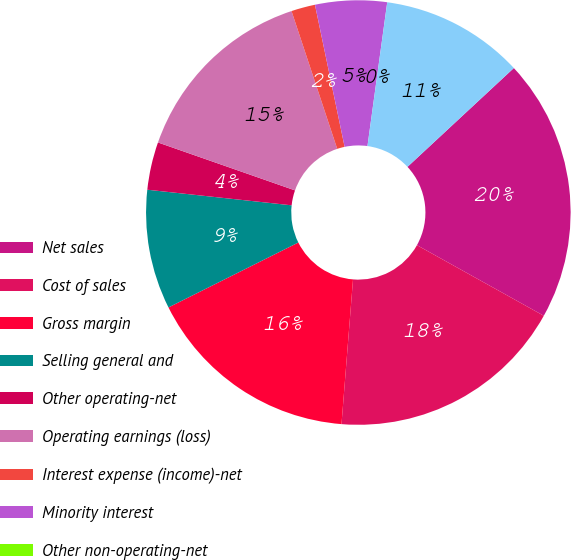Convert chart to OTSL. <chart><loc_0><loc_0><loc_500><loc_500><pie_chart><fcel>Net sales<fcel>Cost of sales<fcel>Gross margin<fcel>Selling general and<fcel>Other operating-net<fcel>Operating earnings (loss)<fcel>Interest expense (income)-net<fcel>Minority interest<fcel>Other non-operating-net<fcel>Earnings (loss) before income<nl><fcel>20.0%<fcel>18.18%<fcel>16.36%<fcel>9.09%<fcel>3.64%<fcel>14.55%<fcel>1.82%<fcel>5.45%<fcel>0.0%<fcel>10.91%<nl></chart> 